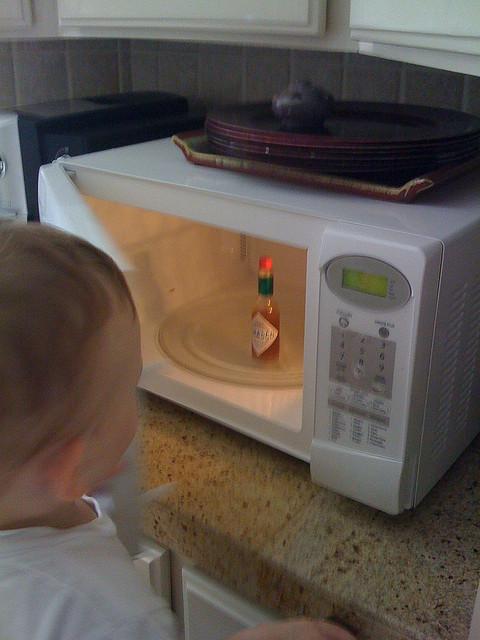What do you need to do first to use this device?
Give a very brief answer. Close door. What is the microwave sitting on?
Keep it brief. Counter. What is this appliance?
Be succinct. Microwave. Would it be wise to cook this item in the microwave?
Short answer required. No. What is in the microwave?
Quick response, please. Tabasco. Where is the microwave oven?
Keep it brief. Counter. Is the baby taller or shorter than the microwave?
Write a very short answer. Taller. How many dishes are there?
Concise answer only. 0. What is the appliance sitting on?
Answer briefly. Counter. What time is it on the microwave clock?
Quick response, please. 0. Is the baby looking at the Tabasco bottle?
Write a very short answer. Yes. 